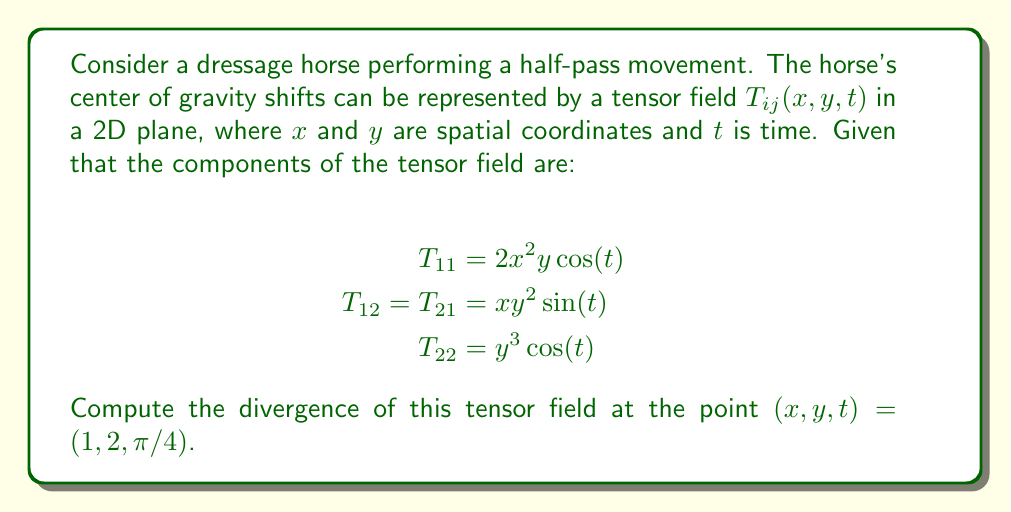Could you help me with this problem? To solve this problem, we need to follow these steps:

1) The divergence of a 2D tensor field $T_{ij}$ is given by:

   $$\text{div}(T) = \frac{\partial T_{11}}{\partial x} + \frac{\partial T_{22}}{\partial y}$$

2) Let's calculate each partial derivative:

   For $T_{11}$:
   $$\frac{\partial T_{11}}{\partial x} = \frac{\partial}{\partial x}(2x^2y\cos(t)) = 4xy\cos(t)$$

   For $T_{22}$:
   $$\frac{\partial T_{22}}{\partial y} = \frac{\partial}{\partial y}(y^3\cos(t)) = 3y^2\cos(t)$$

3) Now, we can substitute these into the divergence formula:

   $$\text{div}(T) = 4xy\cos(t) + 3y^2\cos(t)$$

4) Finally, we evaluate this at the given point $(x,y,t) = (1,2,\pi/4)$:

   $$\text{div}(T)|_{(1,2,\pi/4)} = 4(1)(2)\cos(\pi/4) + 3(2^2)\cos(\pi/4)$$

5) Simplify:
   $$= (8 + 12)\cos(\pi/4) = 20\cos(\pi/4) = 20 \cdot \frac{\sqrt{2}}{2} = 10\sqrt{2}$$
Answer: $10\sqrt{2}$ 